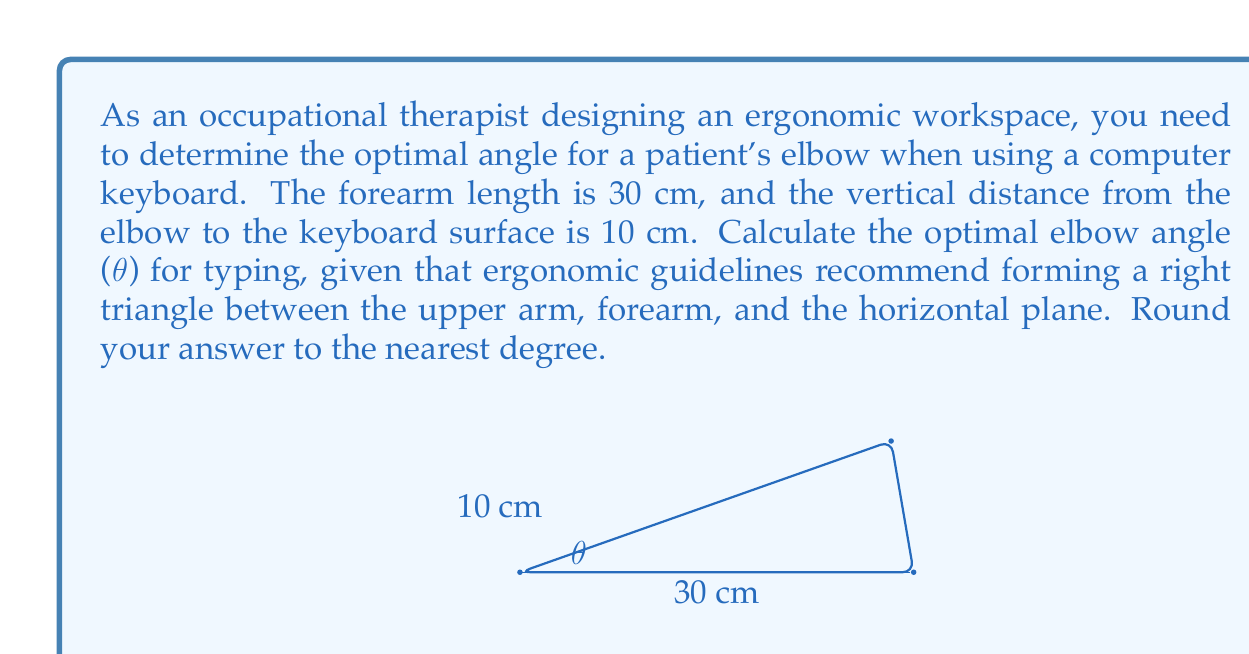Can you solve this math problem? To solve this problem, we'll use trigonometric functions in a right triangle. Let's approach this step-by-step:

1) We have a right triangle where:
   - The hypotenuse is the forearm (30 cm)
   - The opposite side to our angle of interest is the vertical distance (10 cm)
   - The adjacent side is the horizontal distance (unknown)

2) We need to find the angle θ. We can use the inverse sine (arcsin) function:

   $$\theta = \arcsin(\frac{\text{opposite}}{\text{hypotenuse}})$$

3) Plugging in our known values:

   $$\theta = \arcsin(\frac{10}{30})$$

4) Simplify the fraction:

   $$\theta = \arcsin(\frac{1}{3})$$

5) Calculate using a calculator or computer:

   $$\theta \approx 19.47\text{ degrees}$$

6) Rounding to the nearest degree:

   $$\theta \approx 19\text{ degrees}$$

This angle ensures that the forearm forms a right triangle with the upper arm and the horizontal plane, which is considered ergonomically optimal for typing.
Answer: $19\text{ degrees}$ 